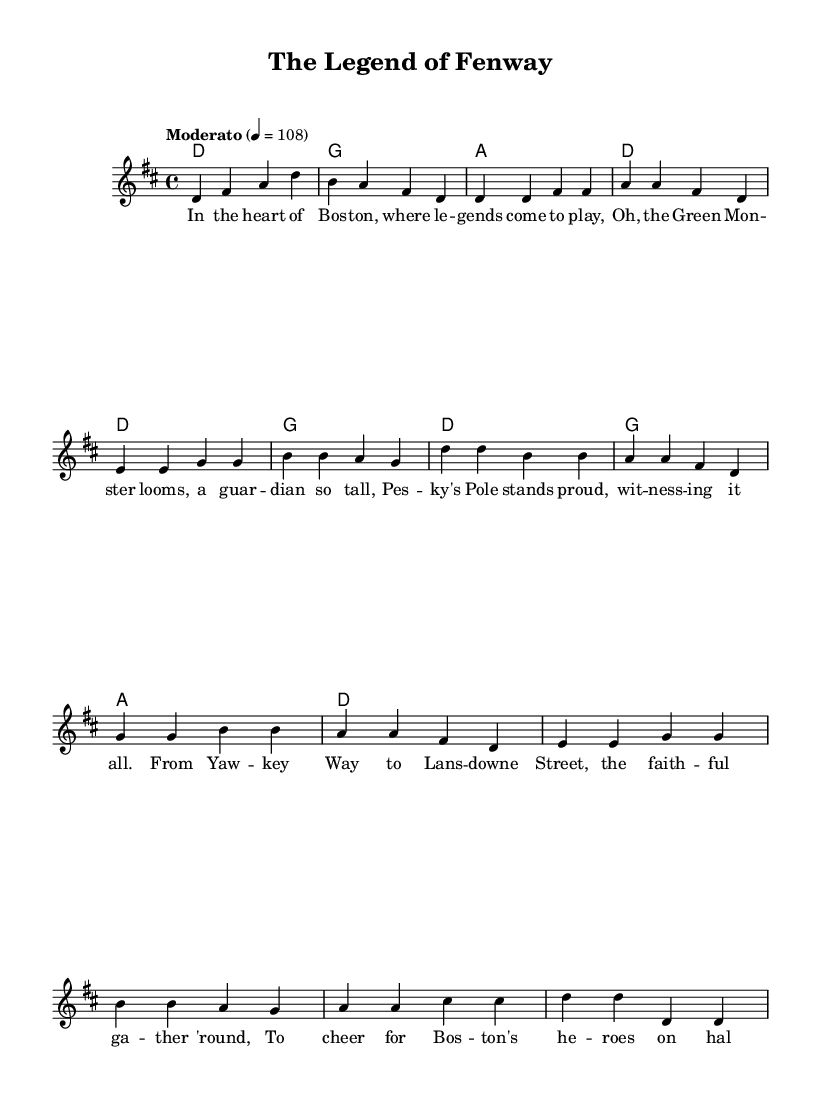What is the key signature of this music? The key signature is indicated at the beginning of the piece, showing two sharps. This corresponds to the D major scale.
Answer: D major What is the time signature of this music? The time signature appears at the beginning, which is represented as 4 over 4. This means there are four beats in each measure.
Answer: 4/4 What is the tempo marking of this piece? The tempo marking is found near the beginning of the score and specifies a moderate speed of quarter note equals 108 beats per minute.
Answer: Moderato How many measures are in the chorus section? To find this, we count the measures designated for the chorus in the music. The chorus contains a total of four measures.
Answer: 4 What are the primary chords used in the intro? The chords for the intro can be observed where they are listed above the melody. They are D, G, A, and D in sequential order.
Answer: D, G, A, D What lyrics illustrate the theme of loyalty to a local sports team? By examining the lyrics, the phrase "the faithful gather 'round" highlights the loyal support of the Boston fans for their heroes.
Answer: "the faithful gather 'round" How does the melody reflect the folk style? The melody features a simple, singable line with repeated phrases, typical of folk music that encourages community singing and storytelling.
Answer: Singable and repetitive 